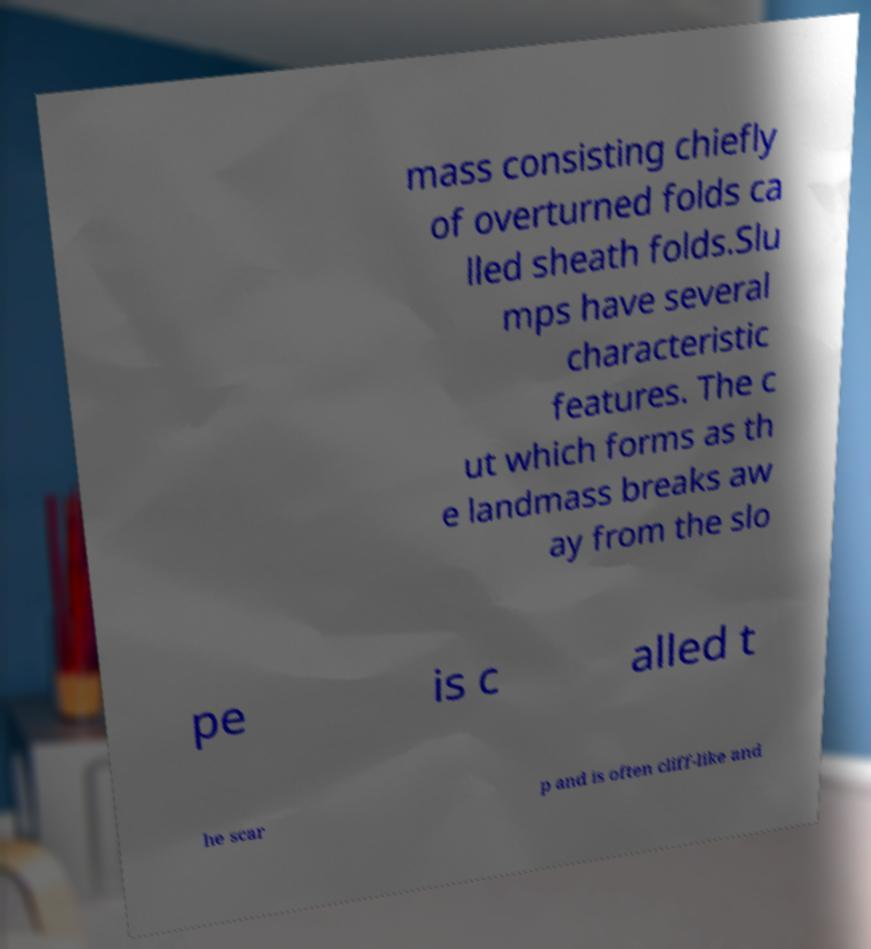Can you accurately transcribe the text from the provided image for me? mass consisting chiefly of overturned folds ca lled sheath folds.Slu mps have several characteristic features. The c ut which forms as th e landmass breaks aw ay from the slo pe is c alled t he scar p and is often cliff-like and 